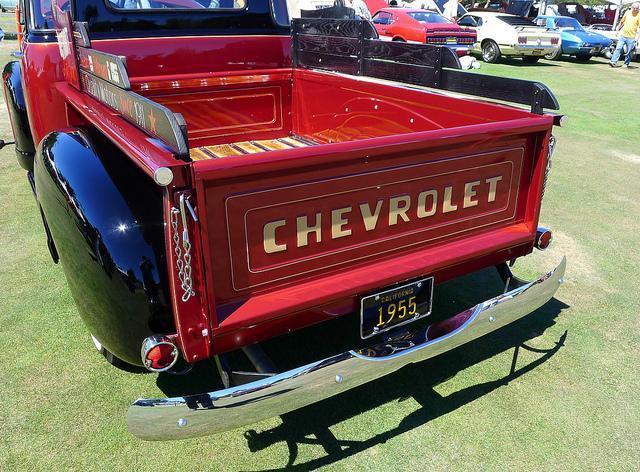How many cars can be seen?
Give a very brief answer. 3. How many buses can be seen in this photo?
Give a very brief answer. 0. 